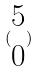Convert formula to latex. <formula><loc_0><loc_0><loc_500><loc_500>( \begin{matrix} 5 \\ 0 \end{matrix} )</formula> 